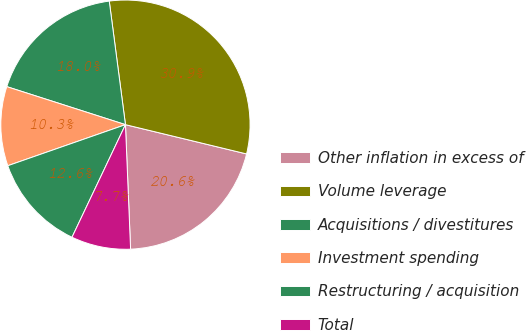<chart> <loc_0><loc_0><loc_500><loc_500><pie_chart><fcel>Other inflation in excess of<fcel>Volume leverage<fcel>Acquisitions / divestitures<fcel>Investment spending<fcel>Restructuring / acquisition<fcel>Total<nl><fcel>20.57%<fcel>30.85%<fcel>17.99%<fcel>10.28%<fcel>12.6%<fcel>7.71%<nl></chart> 